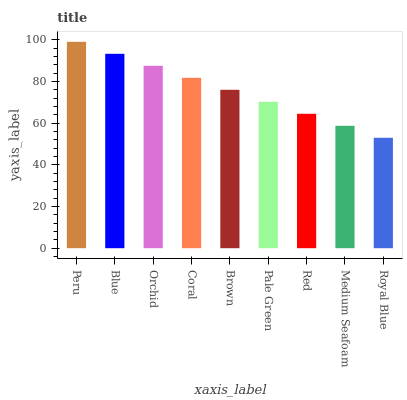Is Royal Blue the minimum?
Answer yes or no. Yes. Is Peru the maximum?
Answer yes or no. Yes. Is Blue the minimum?
Answer yes or no. No. Is Blue the maximum?
Answer yes or no. No. Is Peru greater than Blue?
Answer yes or no. Yes. Is Blue less than Peru?
Answer yes or no. Yes. Is Blue greater than Peru?
Answer yes or no. No. Is Peru less than Blue?
Answer yes or no. No. Is Brown the high median?
Answer yes or no. Yes. Is Brown the low median?
Answer yes or no. Yes. Is Medium Seafoam the high median?
Answer yes or no. No. Is Blue the low median?
Answer yes or no. No. 